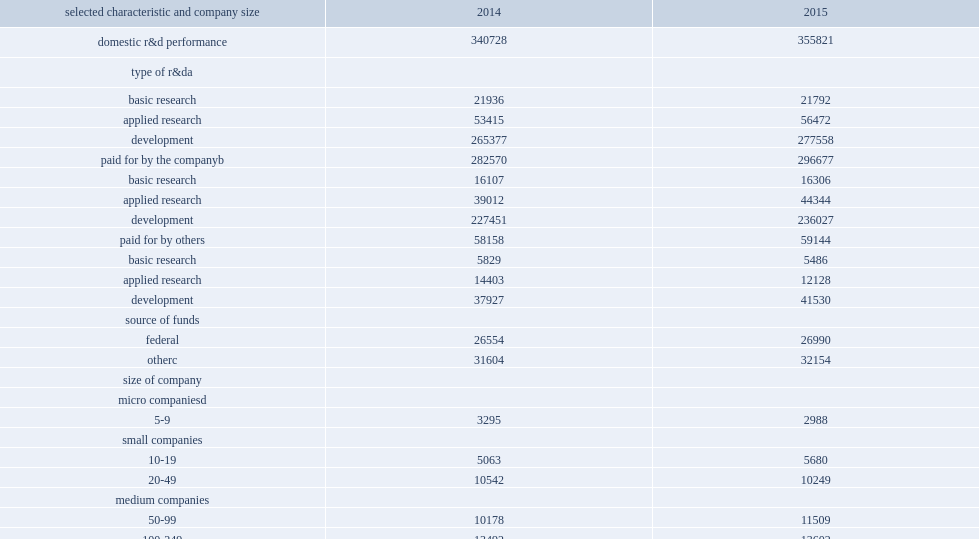How many million dollars did businesses spend on research and development performance in the united states in 2015? 355821.0. How many million dollars did businesses spend on research and development performance in the united states in 2014? 340728.0. Businesses spent $356 billion on research and development performance in the united states in 2015, how many percent of increase over the $341 billion spent in 2014? 0.044296. How many million dollars was funding from the companies' own sources in 2015? 296677.0. How many million dollars was funding from the companies' own sources in 2014? 282570.0. Funding from the companies' own sources was $297 billion in 2015, how many percent of increase from the $283 billion spent in 2014? 0.049924. How many million dollars was funding from other sources in 2015? 59144.0. How many million dollars was funding from other sources in 2014? 58158.0. In 2015, of the $356 million companies spent on r&d, how many million dollars were spent on basic research? 21792.0. In 2015, of the $356 million companies spent on r&d, how many million dollars were spent on applied research? 56472.0. In 2015, of the $356 million companies spent on r&d, how many million dollars were spent on development? 277558.0. Can you parse all the data within this table? {'header': ['selected characteristic and company size', '2014', '2015'], 'rows': [['domestic r&d performance', '340728', '355821'], ['type of r&da', '', ''], ['basic research', '21936', '21792'], ['applied research', '53415', '56472'], ['development', '265377', '277558'], ['paid for by the companyb', '282570', '296677'], ['basic research', '16107', '16306'], ['applied research', '39012', '44344'], ['development', '227451', '236027'], ['paid for by others', '58158', '59144'], ['basic research', '5829', '5486'], ['applied research', '14403', '12128'], ['development', '37927', '41530'], ['source of funds', '', ''], ['federal', '26554', '26990'], ['otherc', '31604', '32154'], ['size of company', '', ''], ['micro companiesd', '', ''], ['5-9', '3295', '2988'], ['small companies', '', ''], ['10-19', '5063', '5680'], ['20-49', '10542', '10249'], ['medium companies', '', ''], ['50-99', '10178', '11509'], ['100-249', '13492', '13602'], ['large companies', '', ''], ['250-499', '12203', '13553'], ['500-999', '13262', '15217'], ['1,000-4,999', '57551', '58094'], ['5,000-9,999', '38202', '38838'], ['10,000-24,999', '54445', '59328'], ['25,000 or more', '122495', '126763']]} 